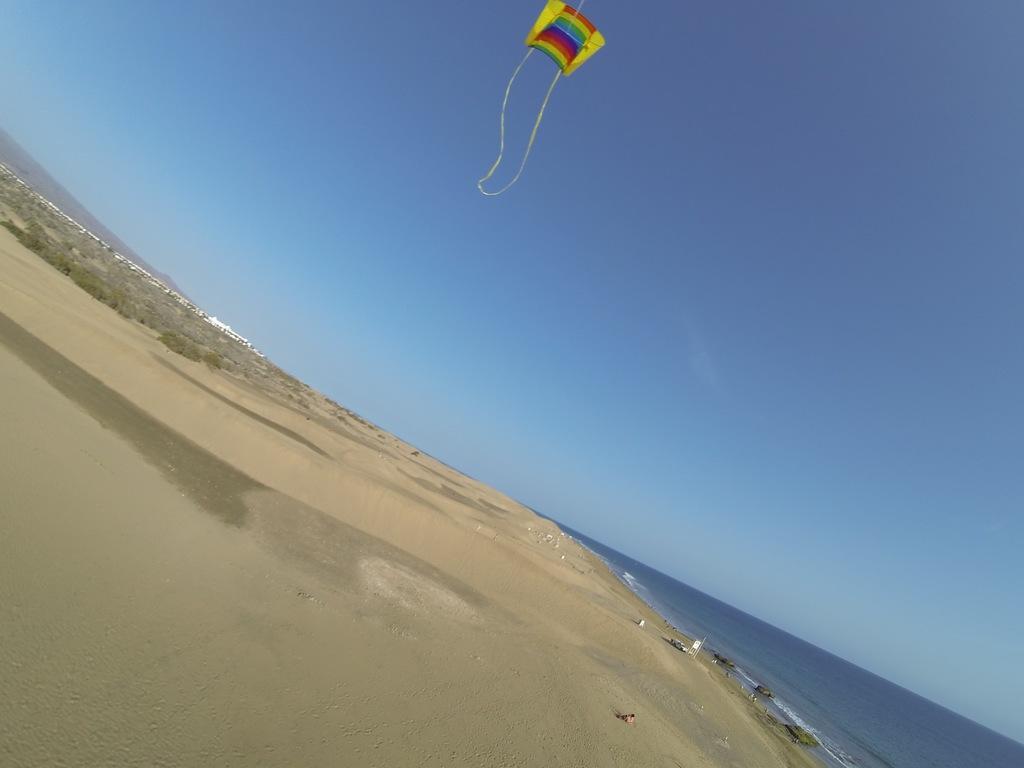Could you give a brief overview of what you see in this image? This image is taken in the beach and here we can see a kite in the sky. At the bottom, there is water and sand. 